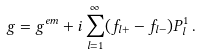<formula> <loc_0><loc_0><loc_500><loc_500>g = g ^ { e m } + i \sum _ { l = 1 } ^ { \infty } ( f _ { l + } - f _ { l - } ) P _ { l } ^ { 1 } \, .</formula> 